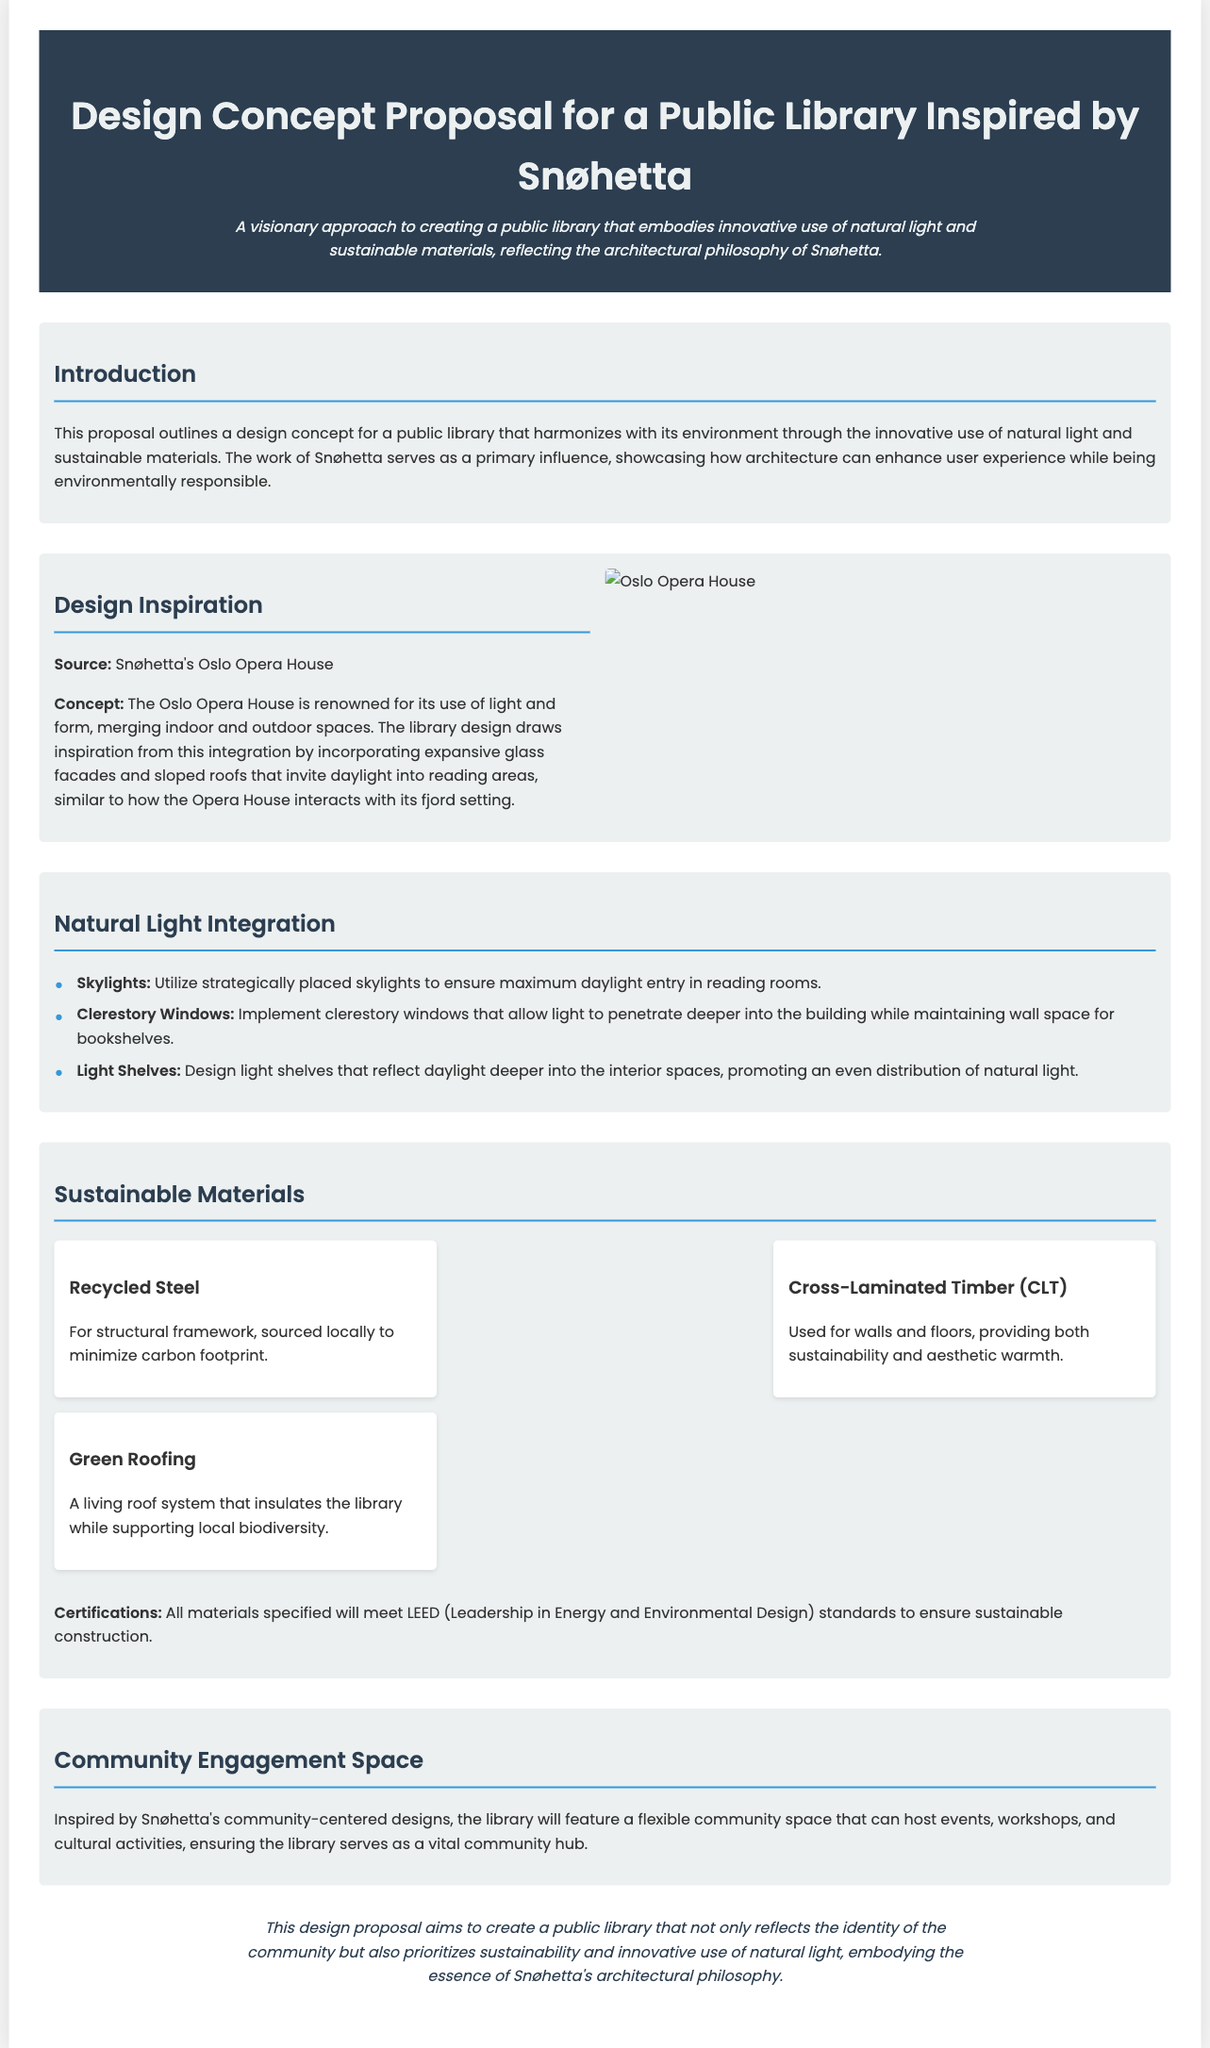what is the primary influence on the library design? The primary influence on the library design is the work of Snøhetta, which showcases how architecture can enhance user experience.
Answer: Snøhetta how many types of windows are mentioned for natural light integration? The document specifies three types of windows utilized for maximum daylight entry: skylights, clerestory windows, and light shelves.
Answer: three what material is used for the structural framework? The design proposal specifies using recycled steel for the structural framework.
Answer: recycled steel what type of roofing system is included in the design? The library design incorporates a living roof system that insulates the library while supporting local biodiversity.
Answer: green roofing how does the library design function as a community hub? The library will feature a flexible community space for events, workshops, and cultural activities, reflecting its role as a vital community hub.
Answer: flexible community space what architectural feature does the library share with the Oslo Opera House? The library incorporates expansive glass facades and sloped roofs to invite daylight into reading areas, similar to the Oslo Opera House.
Answer: expansive glass facades which certification standards will all materials meet? All materials specified in the proposal will meet LEED standards for sustainable construction.
Answer: LEED what aesthetic quality does Cross-Laminated Timber provide? The use of Cross-Laminated Timber offers both sustainability and aesthetic warmth to the library design.
Answer: aesthetic warmth how is natural light intended to be distributed into the interior spaces? Natural light is to be distributed by designing light shelves that reflect daylight deeper into the interior spaces.
Answer: light shelves 